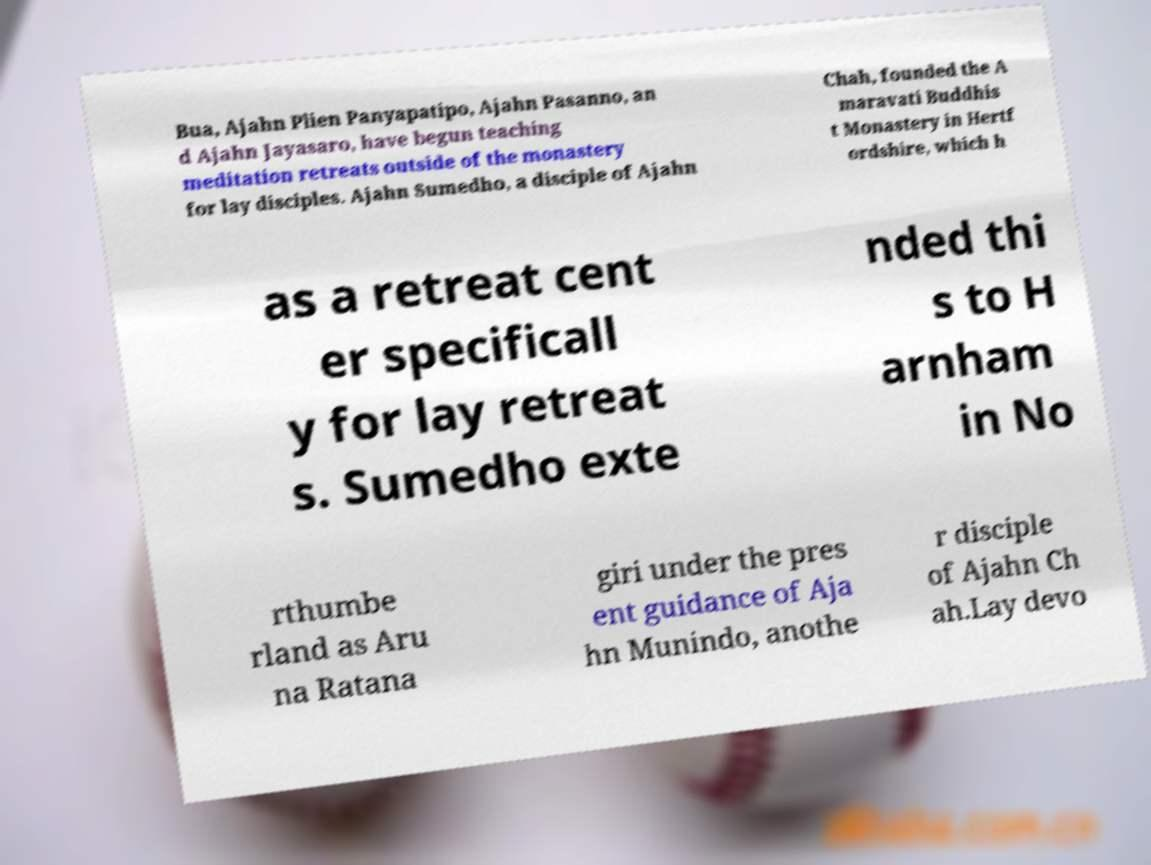Please identify and transcribe the text found in this image. Bua, Ajahn Plien Panyapatipo, Ajahn Pasanno, an d Ajahn Jayasaro, have begun teaching meditation retreats outside of the monastery for lay disciples. Ajahn Sumedho, a disciple of Ajahn Chah, founded the A maravati Buddhis t Monastery in Hertf ordshire, which h as a retreat cent er specificall y for lay retreat s. Sumedho exte nded thi s to H arnham in No rthumbe rland as Aru na Ratana giri under the pres ent guidance of Aja hn Munindo, anothe r disciple of Ajahn Ch ah.Lay devo 